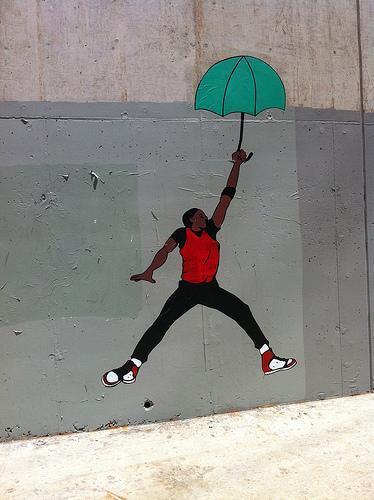How many arm bands are worn?
Give a very brief answer. 1. 